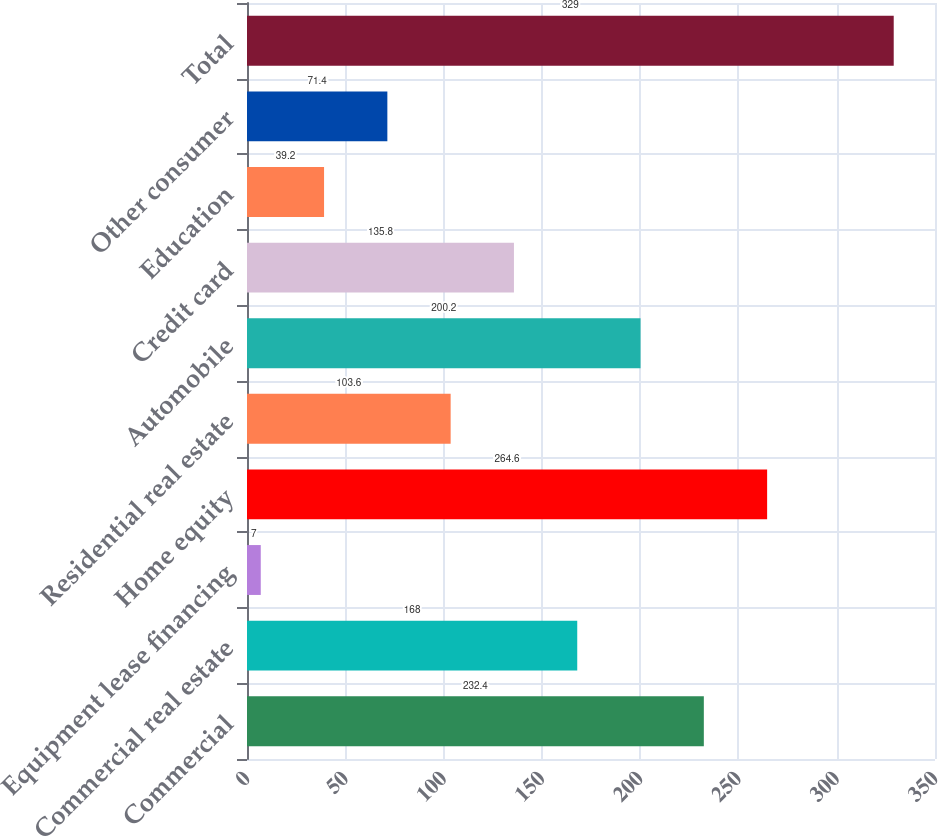<chart> <loc_0><loc_0><loc_500><loc_500><bar_chart><fcel>Commercial<fcel>Commercial real estate<fcel>Equipment lease financing<fcel>Home equity<fcel>Residential real estate<fcel>Automobile<fcel>Credit card<fcel>Education<fcel>Other consumer<fcel>Total<nl><fcel>232.4<fcel>168<fcel>7<fcel>264.6<fcel>103.6<fcel>200.2<fcel>135.8<fcel>39.2<fcel>71.4<fcel>329<nl></chart> 